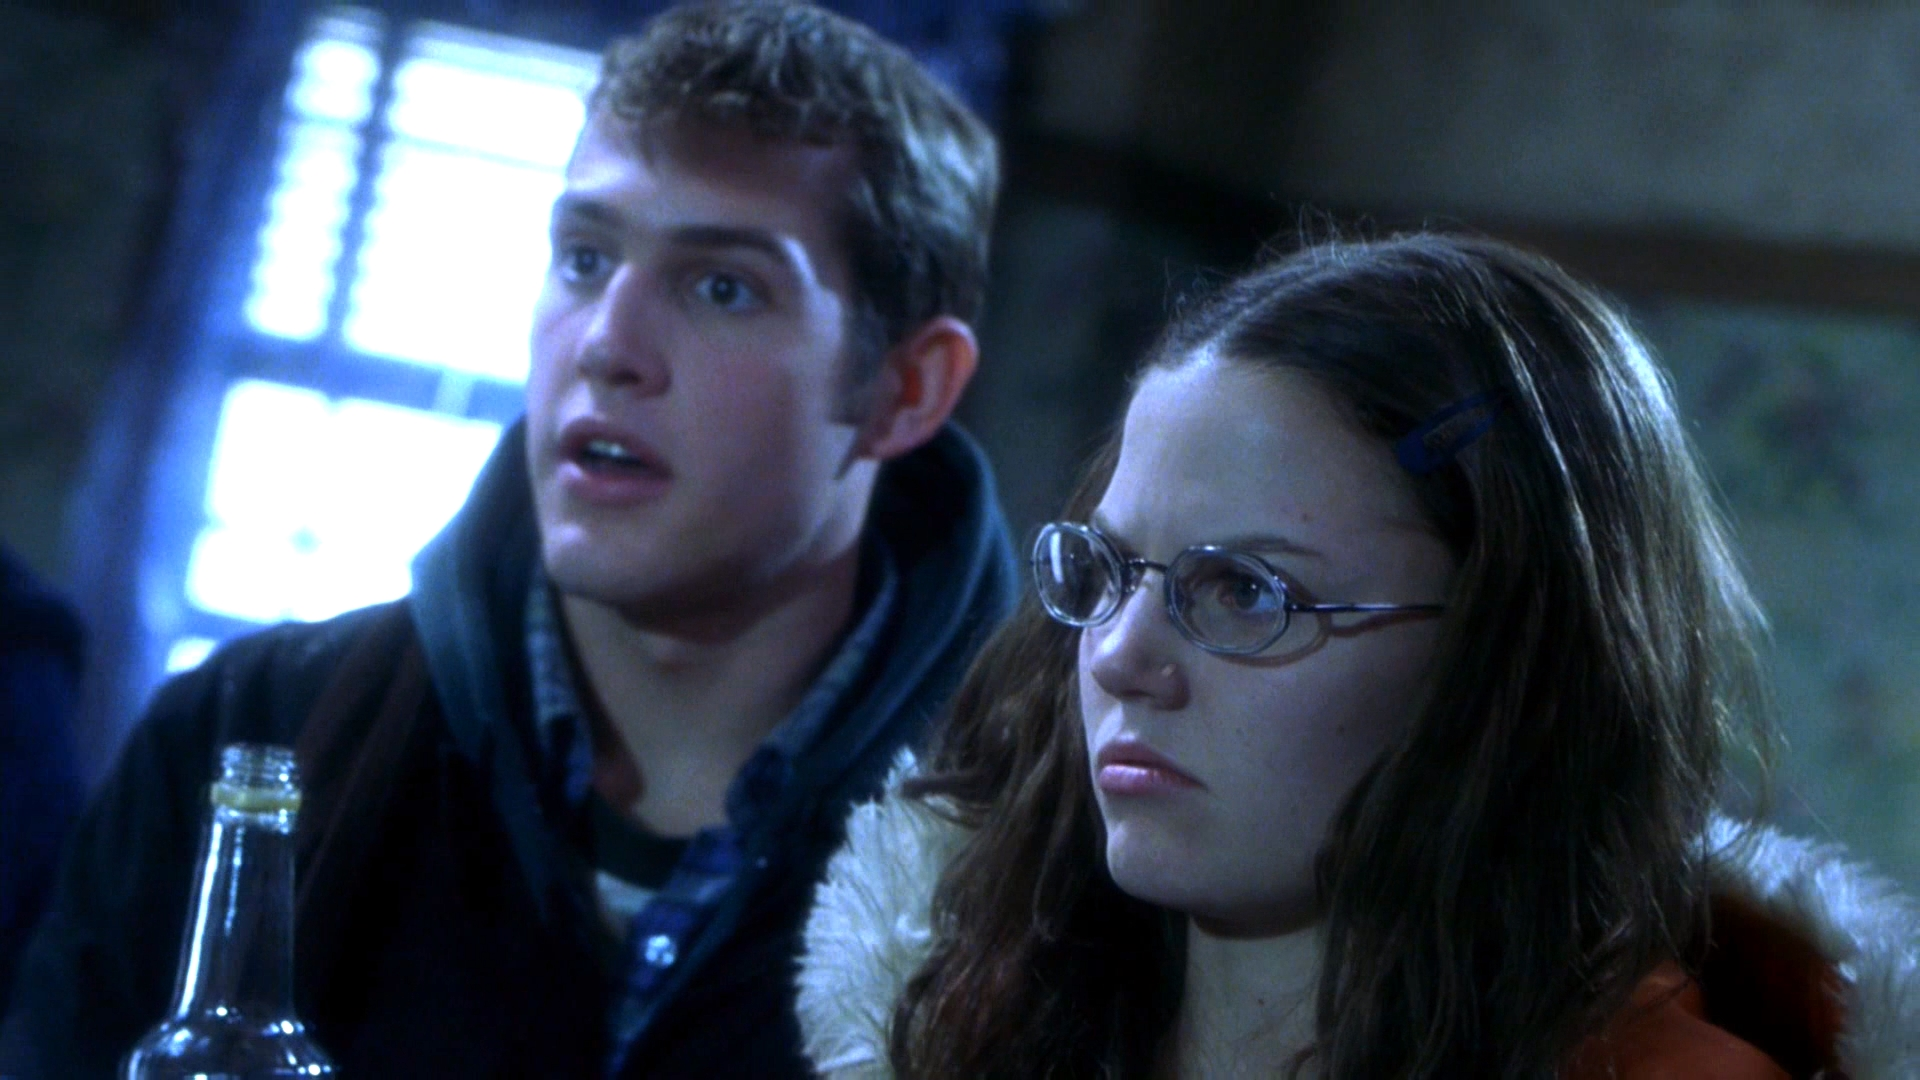What can you infer about the relationship between the two individuals in this image? The relationship between the two individuals in the image appears to be close, given their proximity to each other and their shared focus on something off-screen. The expressions on their faces suggest they might be reacting to a surprising or shocking event together, indicating that they are likely emotionally connected and possibly friends or colleagues. Do you think they are in a dangerous situation? Why or why not? Based on their expressions of shock or surprise and the serious demeanor of the woman with glasses, it seems plausible that they could be in a tense or dangerous situation. The atmosphere is somewhat dark and the background is blurry, which adds to a sense of uncertainty and suspense. The presence of the bottle might also suggest that they are in a distressed state or in an unusual scenario that calls for vigilance. 